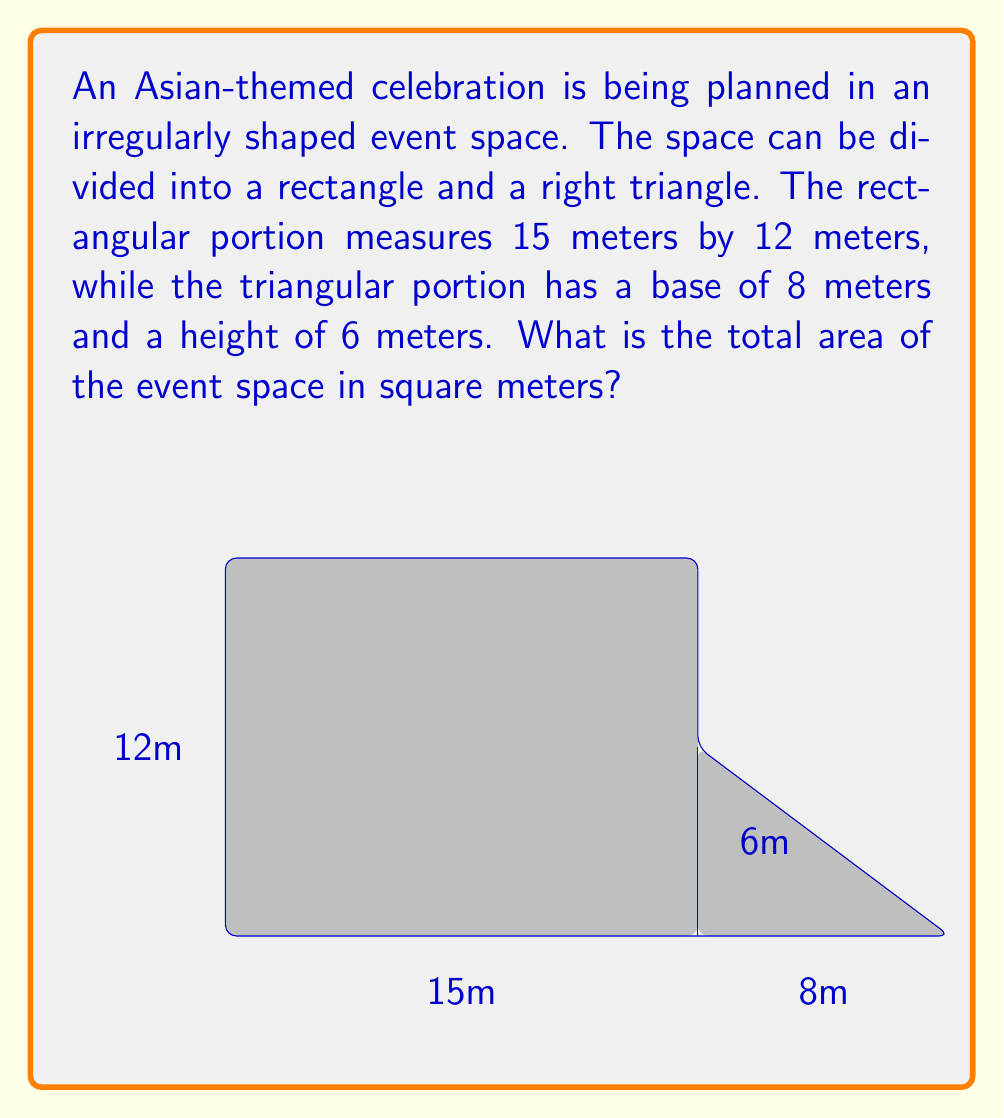Teach me how to tackle this problem. To find the total area of the irregularly shaped event space, we need to calculate the areas of the rectangular portion and the triangular portion separately, then add them together.

1. Area of the rectangular portion:
   $$ A_{rectangle} = length \times width $$
   $$ A_{rectangle} = 15 \text{ m} \times 12 \text{ m} = 180 \text{ m}^2 $$

2. Area of the triangular portion:
   $$ A_{triangle} = \frac{1}{2} \times base \times height $$
   $$ A_{triangle} = \frac{1}{2} \times 8 \text{ m} \times 6 \text{ m} = 24 \text{ m}^2 $$

3. Total area of the event space:
   $$ A_{total} = A_{rectangle} + A_{triangle} $$
   $$ A_{total} = 180 \text{ m}^2 + 24 \text{ m}^2 = 204 \text{ m}^2 $$

Therefore, the total area of the event space is 204 square meters.
Answer: $204 \text{ m}^2$ 